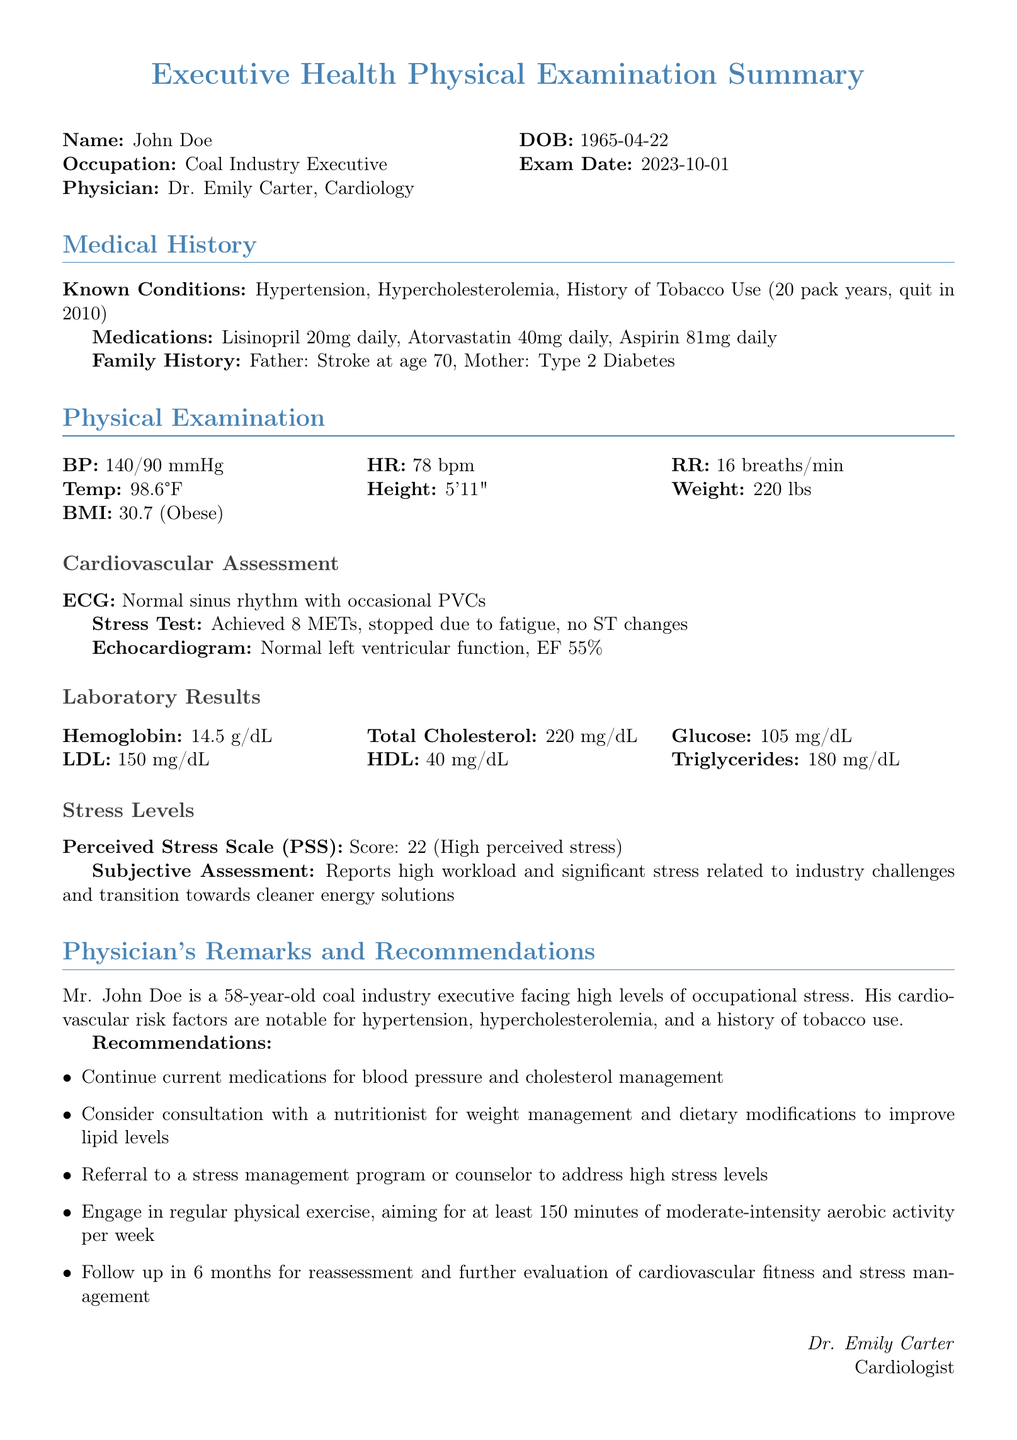What is the name of the patient? The name of the patient is mentioned at the top of the document.
Answer: John Doe What is the patient's date of birth? The date of birth can be found in the header section of the document.
Answer: 1965-04-22 What is the patient's BMI? The BMI is listed under the Physical Examination section.
Answer: 30.7 (Obese) What is the stress test result in METs? The result of the stress test in METs is provided in the Cardiovascular Assessment section.
Answer: 8 METs What is the Perceived Stress Scale score? The Perceived Stress Scale score is detailed under Stress Levels in the document.
Answer: 22 (High perceived stress) What is the current medication for blood pressure? The medications section lists the medications taken by the patient.
Answer: Lisinopril 20mg daily What are the physician's recommendations regarding exercise? The recommendations for exercise can be found in the Physician's Remarks and Recommendations section.
Answer: 150 minutes of moderate-intensity aerobic activity per week What is the result of the echocardiogram regarding left ventricular function? The result of the echocardiogram is specified in the Cardiovascular Assessment section.
Answer: Normal left ventricular function What is the patient's occupational role? The patient's occupation is stated at the beginning of the document.
Answer: Coal Industry Executive 